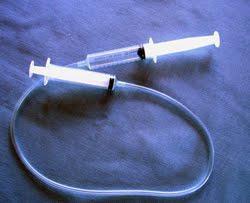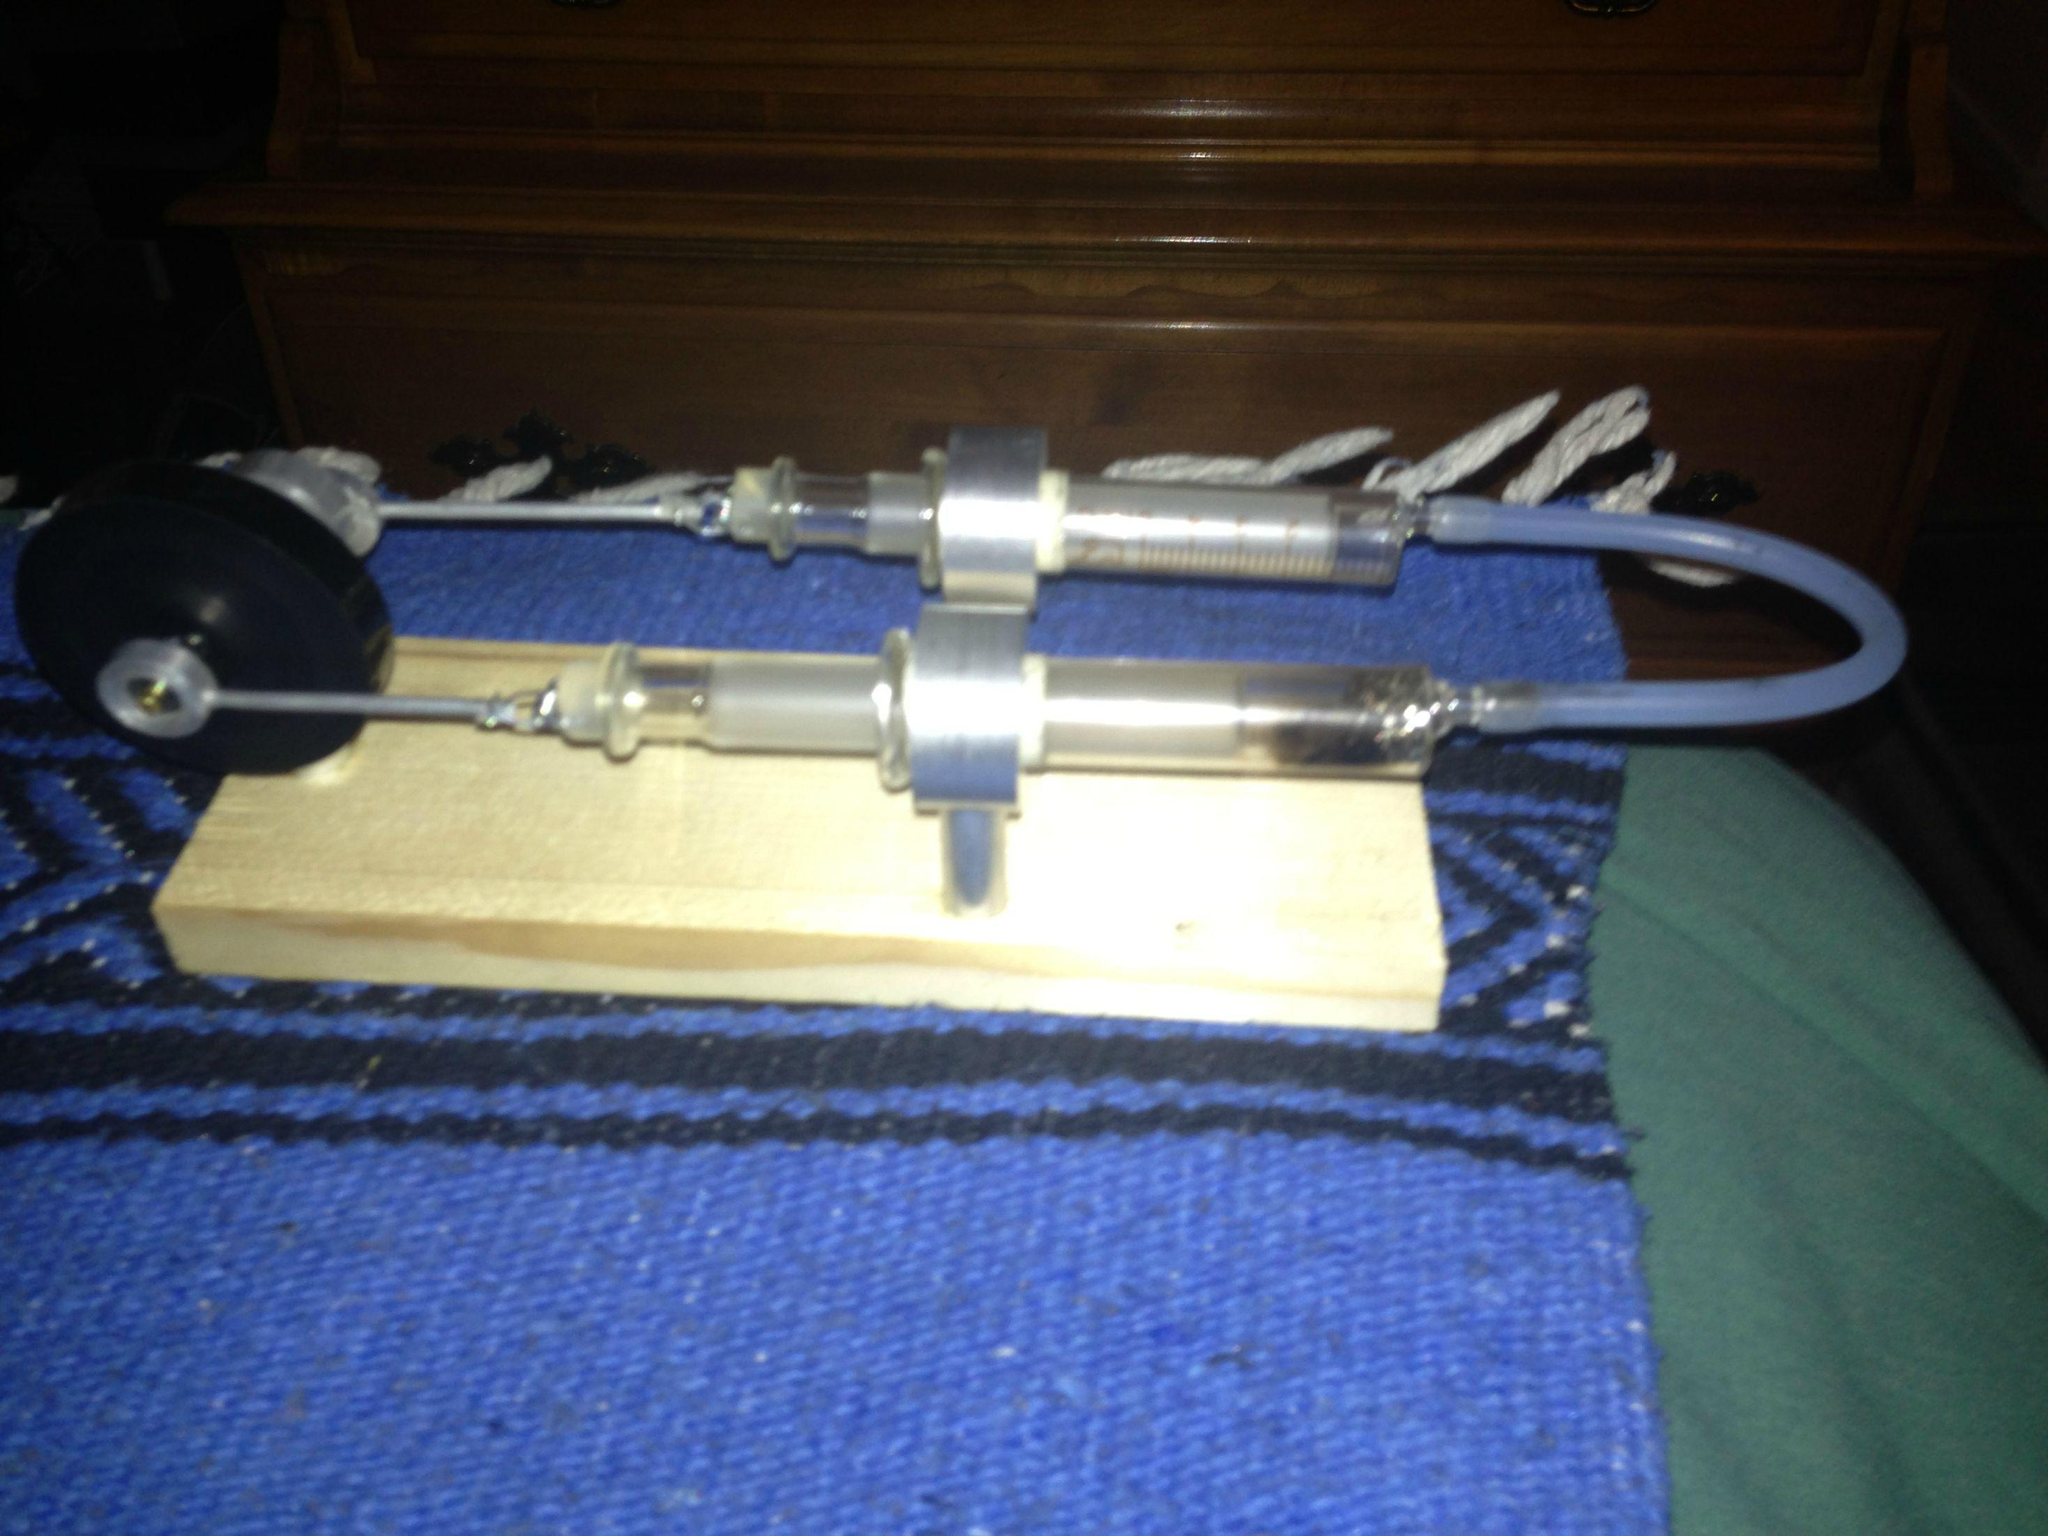The first image is the image on the left, the second image is the image on the right. Considering the images on both sides, is "One syringe is in front of a rectangular item in one image." valid? Answer yes or no. No. The first image is the image on the left, the second image is the image on the right. For the images displayed, is the sentence "The right image shows a pair of syringes that have been used to construct some sort of mechanism with a wheel on it." factually correct? Answer yes or no. Yes. 